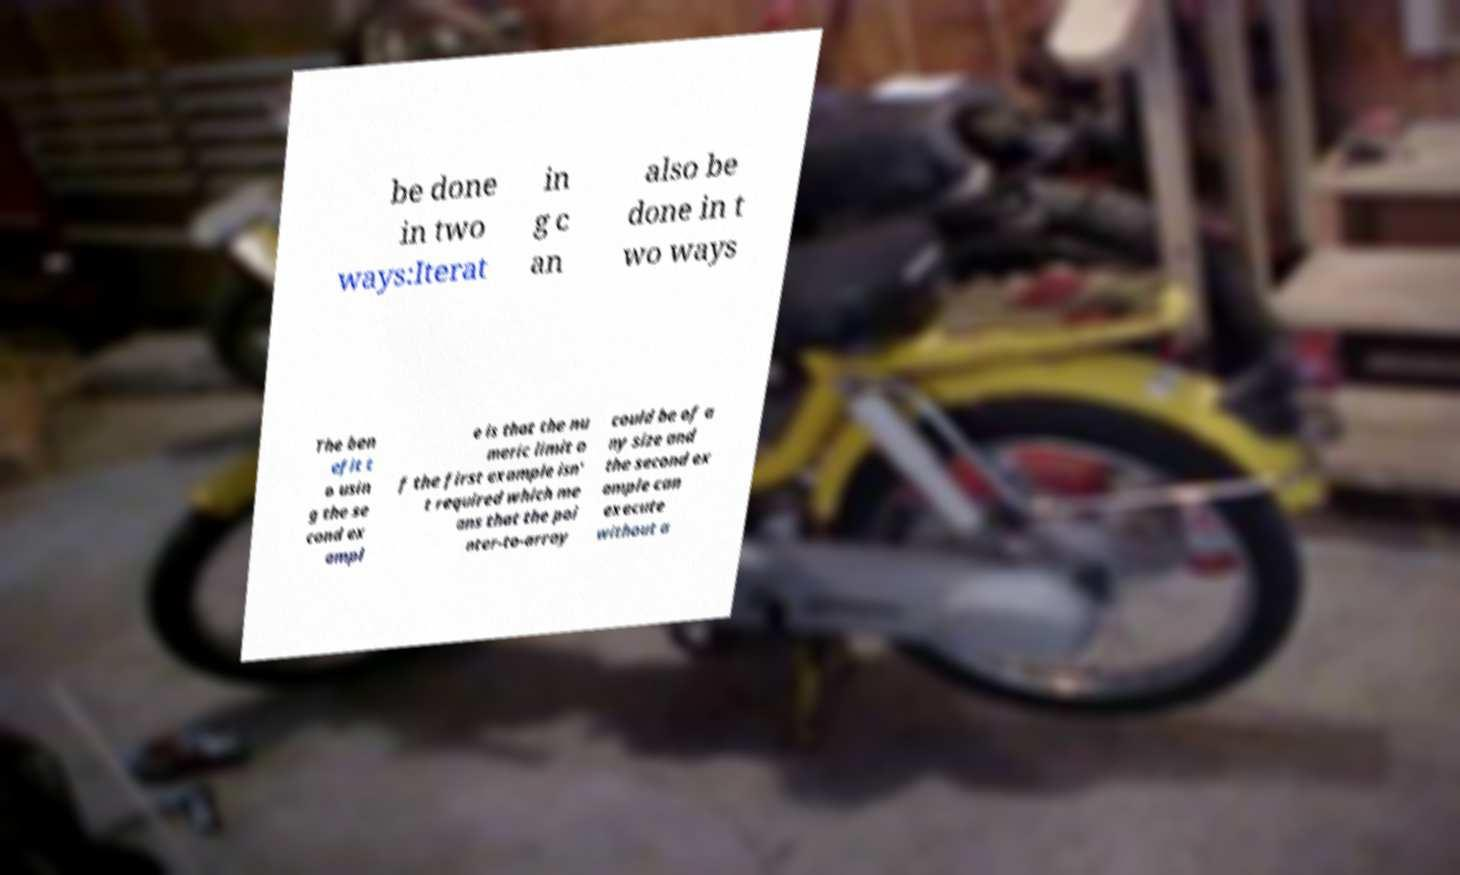For documentation purposes, I need the text within this image transcribed. Could you provide that? be done in two ways:Iterat in g c an also be done in t wo ways The ben efit t o usin g the se cond ex ampl e is that the nu meric limit o f the first example isn' t required which me ans that the poi nter-to-array could be of a ny size and the second ex ample can execute without a 